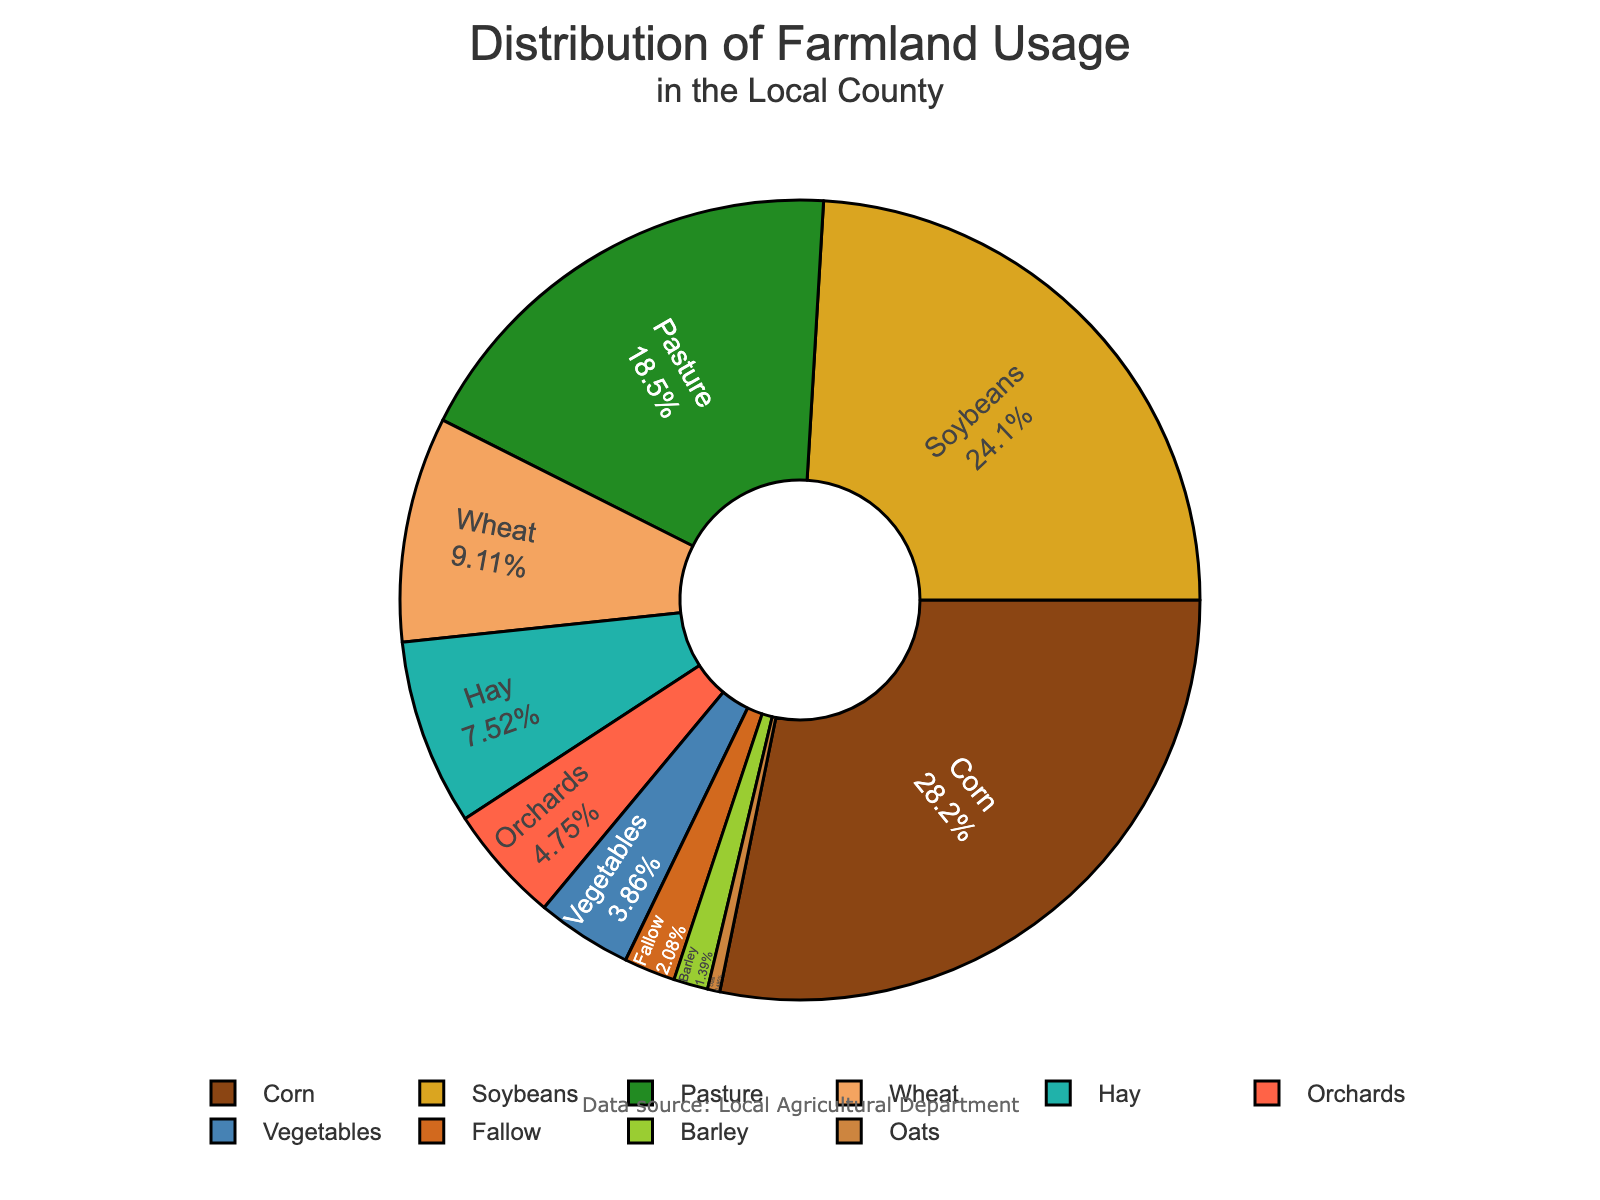What percentage of farmland is used for hay? Look at the pie chart and find the segment labeled "Hay". The percentage is displayed within the segment.
Answer: 7.6% Which crop has the highest farmland usage? Look at the pie chart and find the segment with the largest area. This segment will have the highest percentage.
Answer: Corn What is the combined percentage of farmland used for wheat and barley? Locate the segments labeled "Wheat" and "Barley". Sum their percentages: 9.2% (Wheat) + 1.4% (Barley) = 10.6%.
Answer: 10.6% Is the percentage of farmland used for soybeans greater than for pasture? Compare the sizes of the segments labeled "Soybeans" and "Pasture". Soybeans is 24.3% and Pasture is 18.7%.
Answer: Yes How much more farmland is used for corn compared to oats? Find the difference between the percentage values for "Corn" (28.5%) and "Oats" (0.5%): 28.5% - 0.5% = 28.0%.
Answer: 28.0% What is the average percentage usage of farmland for barley, hay, and oats? Sum the percentages: 1.4% (Barley) + 7.6% (Hay) + 0.5% (Oats) = 9.5%. Then divide by 3: 9.5% / 3 ≈ 3.17%.
Answer: 3.17% Which has a bigger farmland usage, vegetables or orchards? Compare the segments labeled "Vegetables" (3.9%) and "Orchards" (4.8%).
Answer: Orchards What is the total percentage of farmland used for pasture and vegetables together? Add the percentages for "Pasture" (18.7%) and "Vegetables" (3.9%): 18.7% + 3.9% = 22.6%.
Answer: 22.6% Which agricultural use has the smallest percentage of farmland? Find the segment with the smallest area and check its label.
Answer: Oats What percentage of farmland is used for crops other than corn and soybeans? Subtract the combined percentage of corn and soybeans from 100%: 100% - (28.5% + 24.3%) = 100% - 52.8% = 47.2%.
Answer: 47.2% 